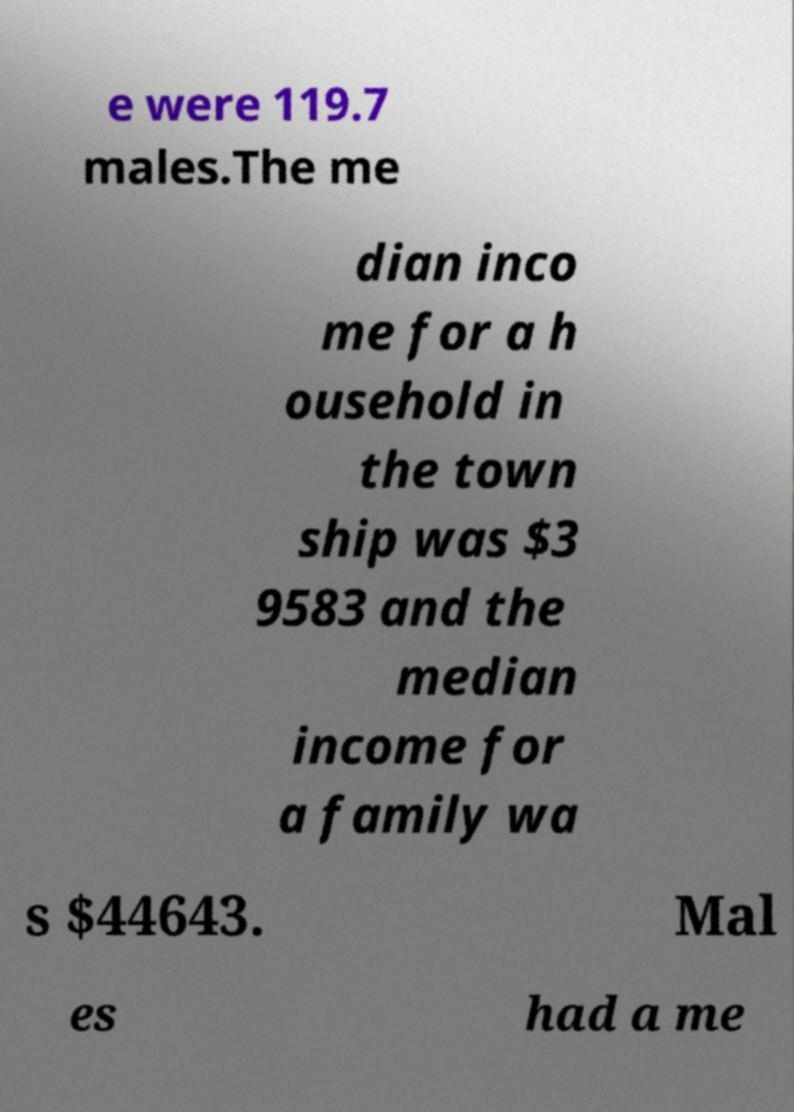Can you accurately transcribe the text from the provided image for me? e were 119.7 males.The me dian inco me for a h ousehold in the town ship was $3 9583 and the median income for a family wa s $44643. Mal es had a me 